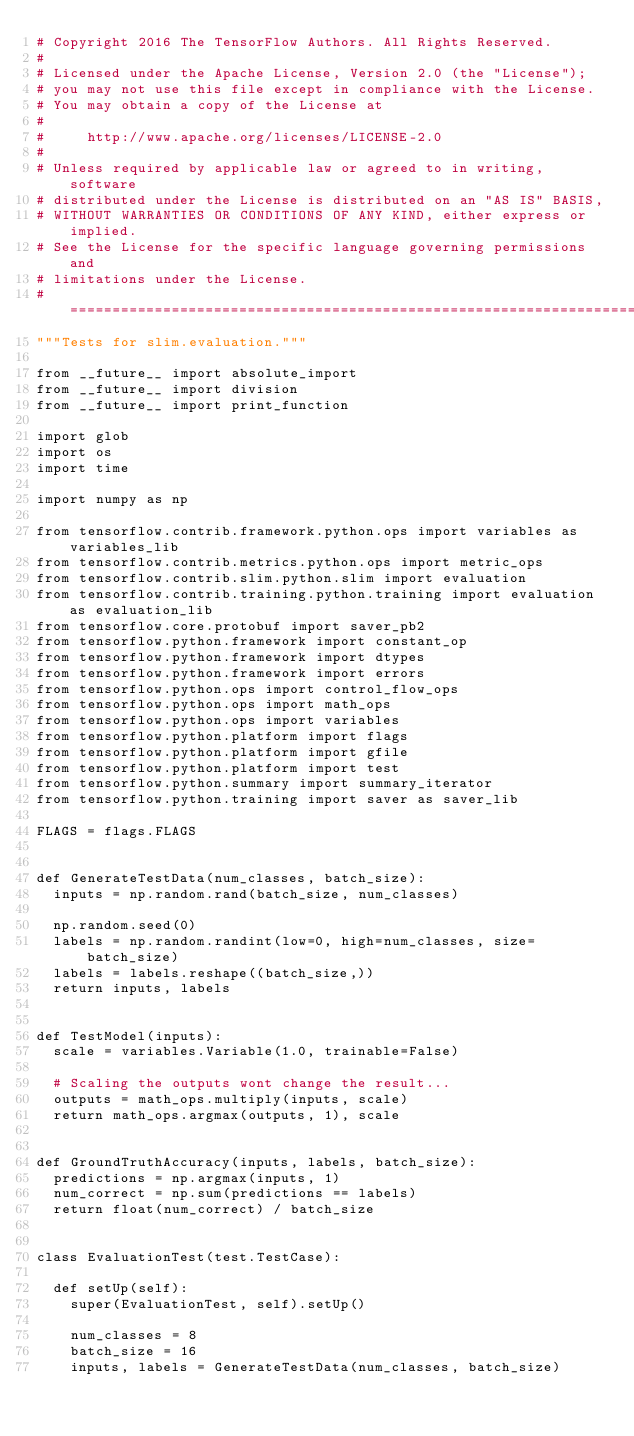<code> <loc_0><loc_0><loc_500><loc_500><_Python_># Copyright 2016 The TensorFlow Authors. All Rights Reserved.
#
# Licensed under the Apache License, Version 2.0 (the "License");
# you may not use this file except in compliance with the License.
# You may obtain a copy of the License at
#
#     http://www.apache.org/licenses/LICENSE-2.0
#
# Unless required by applicable law or agreed to in writing, software
# distributed under the License is distributed on an "AS IS" BASIS,
# WITHOUT WARRANTIES OR CONDITIONS OF ANY KIND, either express or implied.
# See the License for the specific language governing permissions and
# limitations under the License.
# ==============================================================================
"""Tests for slim.evaluation."""

from __future__ import absolute_import
from __future__ import division
from __future__ import print_function

import glob
import os
import time

import numpy as np

from tensorflow.contrib.framework.python.ops import variables as variables_lib
from tensorflow.contrib.metrics.python.ops import metric_ops
from tensorflow.contrib.slim.python.slim import evaluation
from tensorflow.contrib.training.python.training import evaluation as evaluation_lib
from tensorflow.core.protobuf import saver_pb2
from tensorflow.python.framework import constant_op
from tensorflow.python.framework import dtypes
from tensorflow.python.framework import errors
from tensorflow.python.ops import control_flow_ops
from tensorflow.python.ops import math_ops
from tensorflow.python.ops import variables
from tensorflow.python.platform import flags
from tensorflow.python.platform import gfile
from tensorflow.python.platform import test
from tensorflow.python.summary import summary_iterator
from tensorflow.python.training import saver as saver_lib

FLAGS = flags.FLAGS


def GenerateTestData(num_classes, batch_size):
  inputs = np.random.rand(batch_size, num_classes)

  np.random.seed(0)
  labels = np.random.randint(low=0, high=num_classes, size=batch_size)
  labels = labels.reshape((batch_size,))
  return inputs, labels


def TestModel(inputs):
  scale = variables.Variable(1.0, trainable=False)

  # Scaling the outputs wont change the result...
  outputs = math_ops.multiply(inputs, scale)
  return math_ops.argmax(outputs, 1), scale


def GroundTruthAccuracy(inputs, labels, batch_size):
  predictions = np.argmax(inputs, 1)
  num_correct = np.sum(predictions == labels)
  return float(num_correct) / batch_size


class EvaluationTest(test.TestCase):

  def setUp(self):
    super(EvaluationTest, self).setUp()

    num_classes = 8
    batch_size = 16
    inputs, labels = GenerateTestData(num_classes, batch_size)</code> 